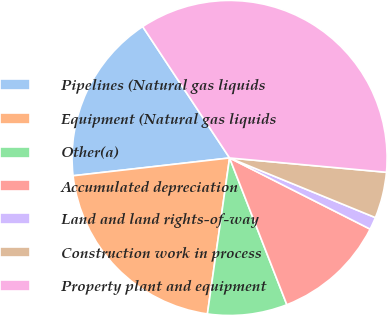Convert chart to OTSL. <chart><loc_0><loc_0><loc_500><loc_500><pie_chart><fcel>Pipelines (Natural gas liquids<fcel>Equipment (Natural gas liquids<fcel>Other(a)<fcel>Accumulated depreciation<fcel>Land and land rights-of-way<fcel>Construction work in process<fcel>Property plant and equipment<nl><fcel>17.5%<fcel>20.95%<fcel>8.17%<fcel>11.62%<fcel>1.28%<fcel>4.73%<fcel>35.75%<nl></chart> 